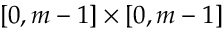Convert formula to latex. <formula><loc_0><loc_0><loc_500><loc_500>[ 0 , m - 1 ] \times [ 0 , m - 1 ]</formula> 